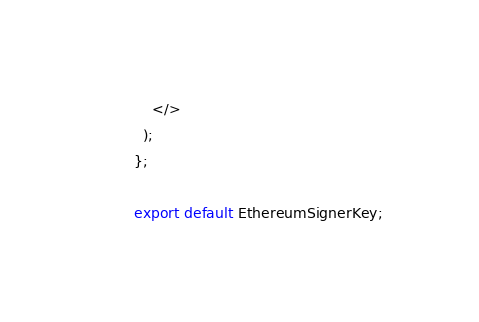<code> <loc_0><loc_0><loc_500><loc_500><_TypeScript_>    </>
  );
};

export default EthereumSignerKey;
</code> 